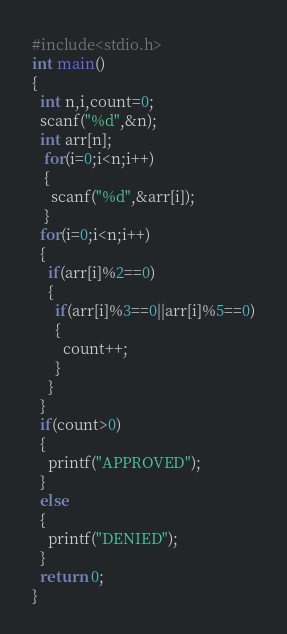Convert code to text. <code><loc_0><loc_0><loc_500><loc_500><_C_>#include<stdio.h>
int main()
{
  int n,i,count=0;
  scanf("%d",&n);
  int arr[n];
   for(i=0;i<n;i++)
   {
     scanf("%d",&arr[i]);
   }
  for(i=0;i<n;i++)
  {
    if(arr[i]%2==0)
    {
      if(arr[i]%3==0||arr[i]%5==0)
      {
        count++;
      }
    }
  }
  if(count>0)
  {
    printf("APPROVED");
  }
  else
  {
    printf("DENIED");
  }
  return 0;
}
</code> 